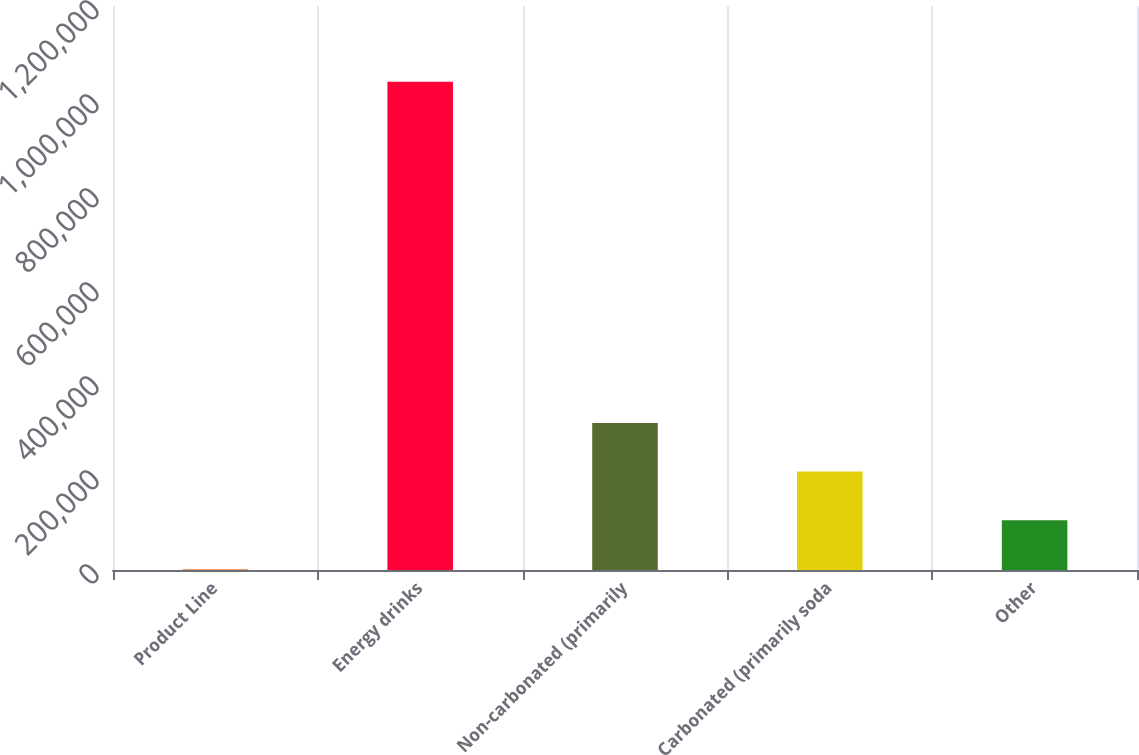Convert chart to OTSL. <chart><loc_0><loc_0><loc_500><loc_500><bar_chart><fcel>Product Line<fcel>Energy drinks<fcel>Non-carbonated (primarily<fcel>Carbonated (primarily soda<fcel>Other<nl><fcel>2009<fcel>1.03857e+06<fcel>312978<fcel>209322<fcel>105665<nl></chart> 